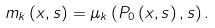Convert formula to latex. <formula><loc_0><loc_0><loc_500><loc_500>m _ { k } \left ( x , s \right ) = \mu _ { k } \left ( P _ { 0 } \left ( x , s \right ) , s \right ) .</formula> 